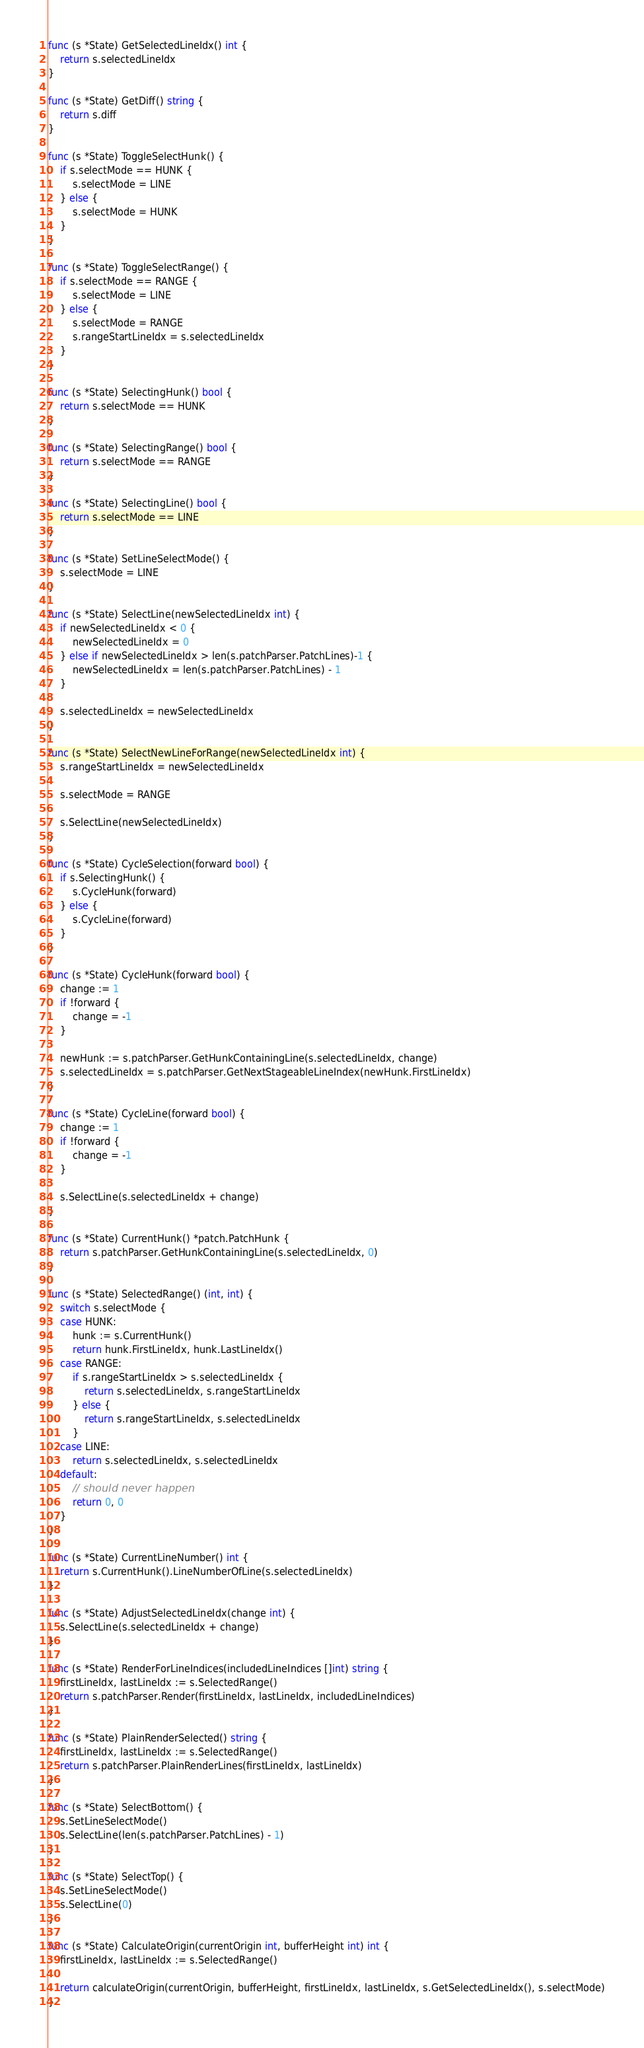Convert code to text. <code><loc_0><loc_0><loc_500><loc_500><_Go_>
func (s *State) GetSelectedLineIdx() int {
	return s.selectedLineIdx
}

func (s *State) GetDiff() string {
	return s.diff
}

func (s *State) ToggleSelectHunk() {
	if s.selectMode == HUNK {
		s.selectMode = LINE
	} else {
		s.selectMode = HUNK
	}
}

func (s *State) ToggleSelectRange() {
	if s.selectMode == RANGE {
		s.selectMode = LINE
	} else {
		s.selectMode = RANGE
		s.rangeStartLineIdx = s.selectedLineIdx
	}
}

func (s *State) SelectingHunk() bool {
	return s.selectMode == HUNK
}

func (s *State) SelectingRange() bool {
	return s.selectMode == RANGE
}

func (s *State) SelectingLine() bool {
	return s.selectMode == LINE
}

func (s *State) SetLineSelectMode() {
	s.selectMode = LINE
}

func (s *State) SelectLine(newSelectedLineIdx int) {
	if newSelectedLineIdx < 0 {
		newSelectedLineIdx = 0
	} else if newSelectedLineIdx > len(s.patchParser.PatchLines)-1 {
		newSelectedLineIdx = len(s.patchParser.PatchLines) - 1
	}

	s.selectedLineIdx = newSelectedLineIdx
}

func (s *State) SelectNewLineForRange(newSelectedLineIdx int) {
	s.rangeStartLineIdx = newSelectedLineIdx

	s.selectMode = RANGE

	s.SelectLine(newSelectedLineIdx)
}

func (s *State) CycleSelection(forward bool) {
	if s.SelectingHunk() {
		s.CycleHunk(forward)
	} else {
		s.CycleLine(forward)
	}
}

func (s *State) CycleHunk(forward bool) {
	change := 1
	if !forward {
		change = -1
	}

	newHunk := s.patchParser.GetHunkContainingLine(s.selectedLineIdx, change)
	s.selectedLineIdx = s.patchParser.GetNextStageableLineIndex(newHunk.FirstLineIdx)
}

func (s *State) CycleLine(forward bool) {
	change := 1
	if !forward {
		change = -1
	}

	s.SelectLine(s.selectedLineIdx + change)
}

func (s *State) CurrentHunk() *patch.PatchHunk {
	return s.patchParser.GetHunkContainingLine(s.selectedLineIdx, 0)
}

func (s *State) SelectedRange() (int, int) {
	switch s.selectMode {
	case HUNK:
		hunk := s.CurrentHunk()
		return hunk.FirstLineIdx, hunk.LastLineIdx()
	case RANGE:
		if s.rangeStartLineIdx > s.selectedLineIdx {
			return s.selectedLineIdx, s.rangeStartLineIdx
		} else {
			return s.rangeStartLineIdx, s.selectedLineIdx
		}
	case LINE:
		return s.selectedLineIdx, s.selectedLineIdx
	default:
		// should never happen
		return 0, 0
	}
}

func (s *State) CurrentLineNumber() int {
	return s.CurrentHunk().LineNumberOfLine(s.selectedLineIdx)
}

func (s *State) AdjustSelectedLineIdx(change int) {
	s.SelectLine(s.selectedLineIdx + change)
}

func (s *State) RenderForLineIndices(includedLineIndices []int) string {
	firstLineIdx, lastLineIdx := s.SelectedRange()
	return s.patchParser.Render(firstLineIdx, lastLineIdx, includedLineIndices)
}

func (s *State) PlainRenderSelected() string {
	firstLineIdx, lastLineIdx := s.SelectedRange()
	return s.patchParser.PlainRenderLines(firstLineIdx, lastLineIdx)
}

func (s *State) SelectBottom() {
	s.SetLineSelectMode()
	s.SelectLine(len(s.patchParser.PatchLines) - 1)
}

func (s *State) SelectTop() {
	s.SetLineSelectMode()
	s.SelectLine(0)
}

func (s *State) CalculateOrigin(currentOrigin int, bufferHeight int) int {
	firstLineIdx, lastLineIdx := s.SelectedRange()

	return calculateOrigin(currentOrigin, bufferHeight, firstLineIdx, lastLineIdx, s.GetSelectedLineIdx(), s.selectMode)
}
</code> 